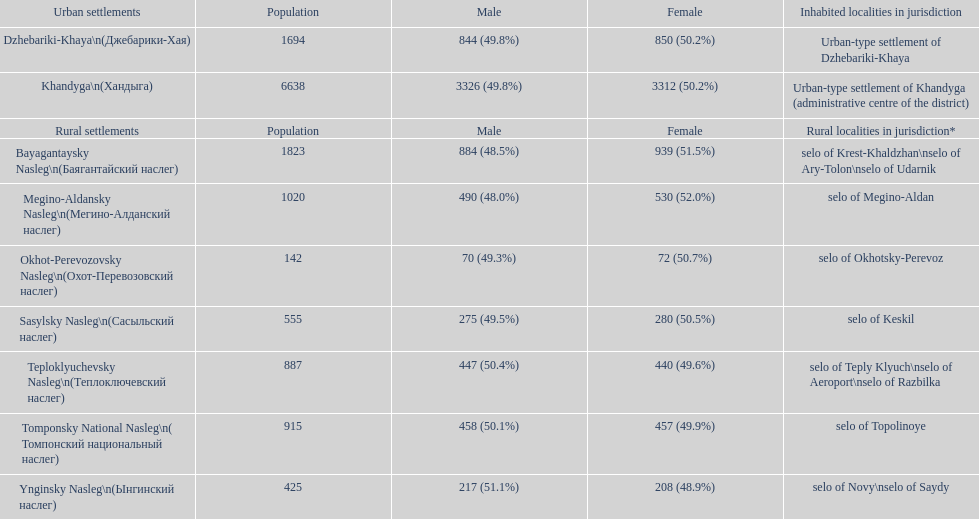How many cities are below 1000 in population? 5. 